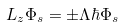Convert formula to latex. <formula><loc_0><loc_0><loc_500><loc_500>L _ { z } \Phi _ { s } = \pm \Lambda \hbar { \Phi } _ { s }</formula> 